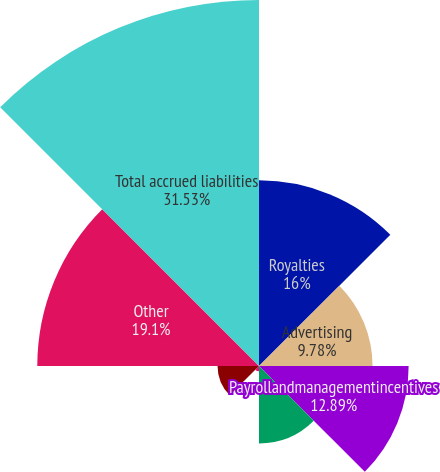Convert chart to OTSL. <chart><loc_0><loc_0><loc_500><loc_500><pie_chart><fcel>Royalties<fcel>Advertising<fcel>Payrollandmanagementincentives<fcel>Dividends<fcel>Severance<fcel>OtherTaxes<fcel>Other<fcel>Total accrued liabilities<nl><fcel>16.0%<fcel>9.78%<fcel>12.89%<fcel>6.67%<fcel>0.46%<fcel>3.57%<fcel>19.1%<fcel>31.53%<nl></chart> 